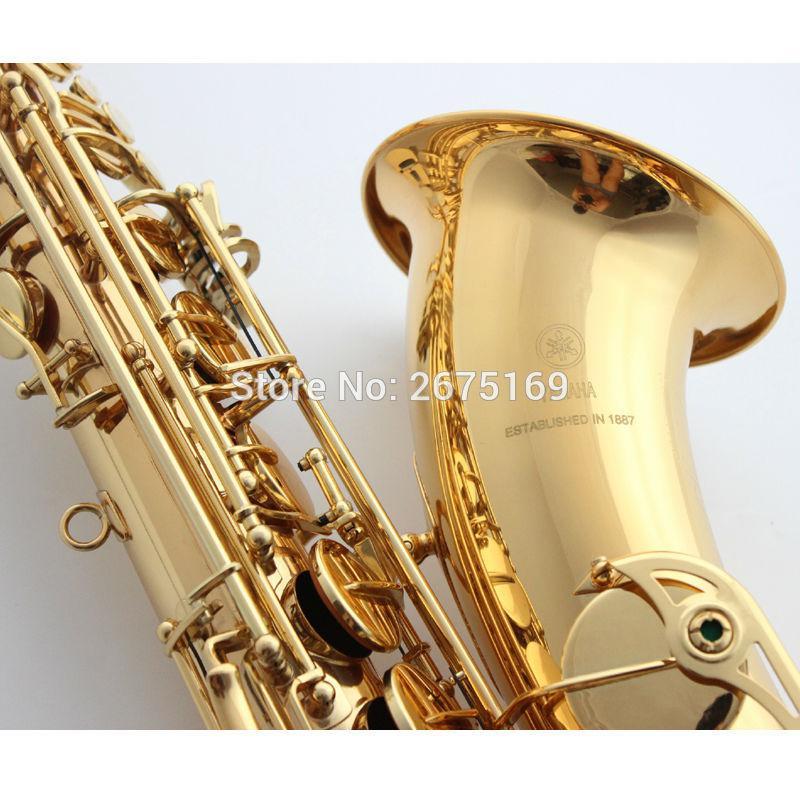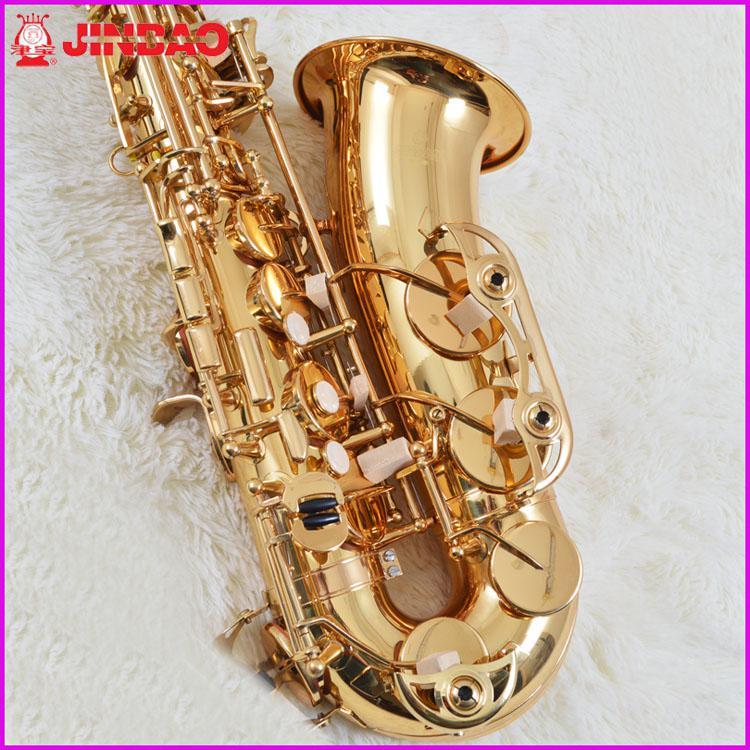The first image is the image on the left, the second image is the image on the right. Evaluate the accuracy of this statement regarding the images: "The entire saxophone is visible in each image.". Is it true? Answer yes or no. No. 